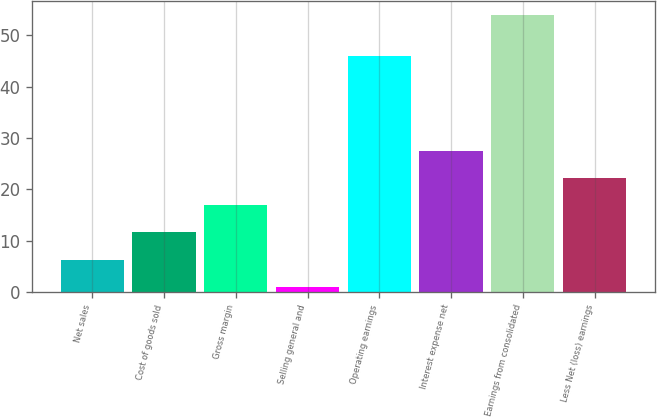<chart> <loc_0><loc_0><loc_500><loc_500><bar_chart><fcel>Net sales<fcel>Cost of goods sold<fcel>Gross margin<fcel>Selling general and<fcel>Operating earnings<fcel>Interest expense net<fcel>Earnings from consolidated<fcel>Less Net (loss) earnings<nl><fcel>6.3<fcel>11.6<fcel>16.9<fcel>1<fcel>46<fcel>27.5<fcel>54<fcel>22.2<nl></chart> 